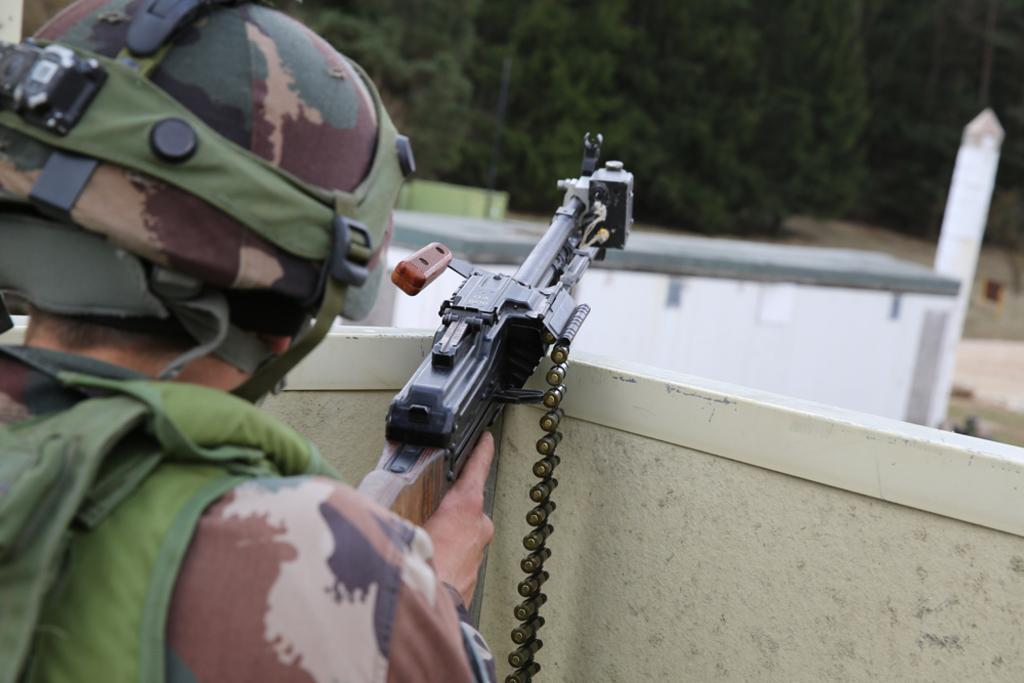Who or what is present in the image? There is a person in the image. What is the person wearing? The person is wearing a helmet. What is the person holding? The person is holding a gun. What can be seen in the background of the image? There is a wall and trees in the background of the image. What type of quill is the person using to write on the wall in the image? There is no quill present in the image, nor is the person writing on the wall. 